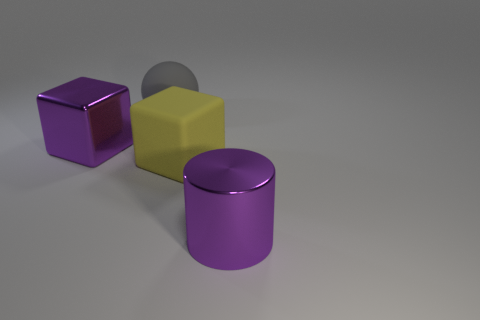What can you tell me about the lighting and shadows in the scene? The lighting in the scene appears to be diffused, possibly from an overhead source, judging by the soft shadows cast by the objects onto the surface below them. These shadows are gentle and elongated, indicating that the light source is not directly above but at an angle, illuminating the scene consistently without creating harsh contrasts. 